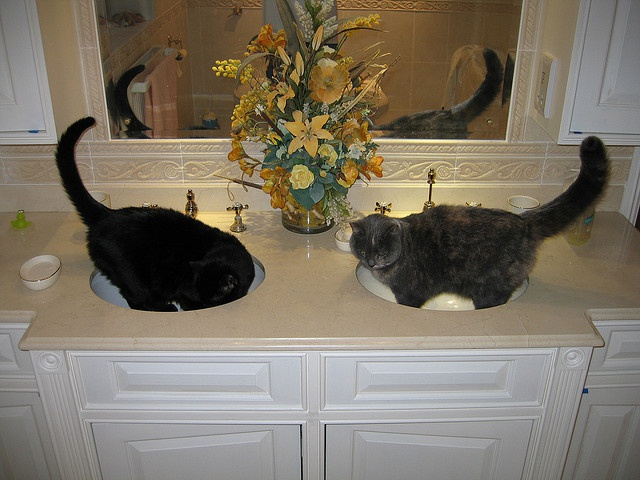Describe the objects in this image and their specific colors. I can see potted plant in gray, olive, black, and tan tones, cat in gray and black tones, cat in gray and black tones, sink in gray, darkgray, and black tones, and sink in gray and black tones in this image. 